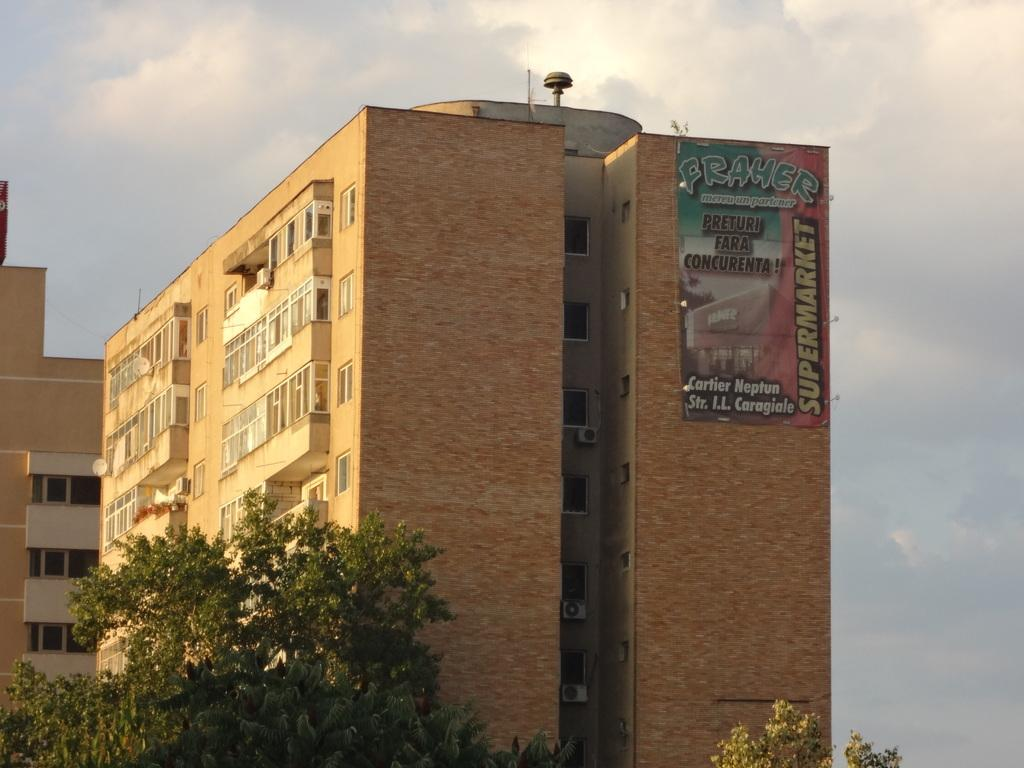What type of vegetation can be seen in the image? There are trees in the image. What is located behind the trees? There are buildings behind the trees. What is on one of the buildings? There is a banner on one of the buildings. What can be seen in the background of the image? The sky is visible behind the buildings. How would you describe the sky in the image? The sky appears to be cloudy. What type of rake is being used to patch the popcorn on the building in the image? There is no rake, patch, or popcorn present in the image. The image features trees, buildings, a banner, and a cloudy sky. 